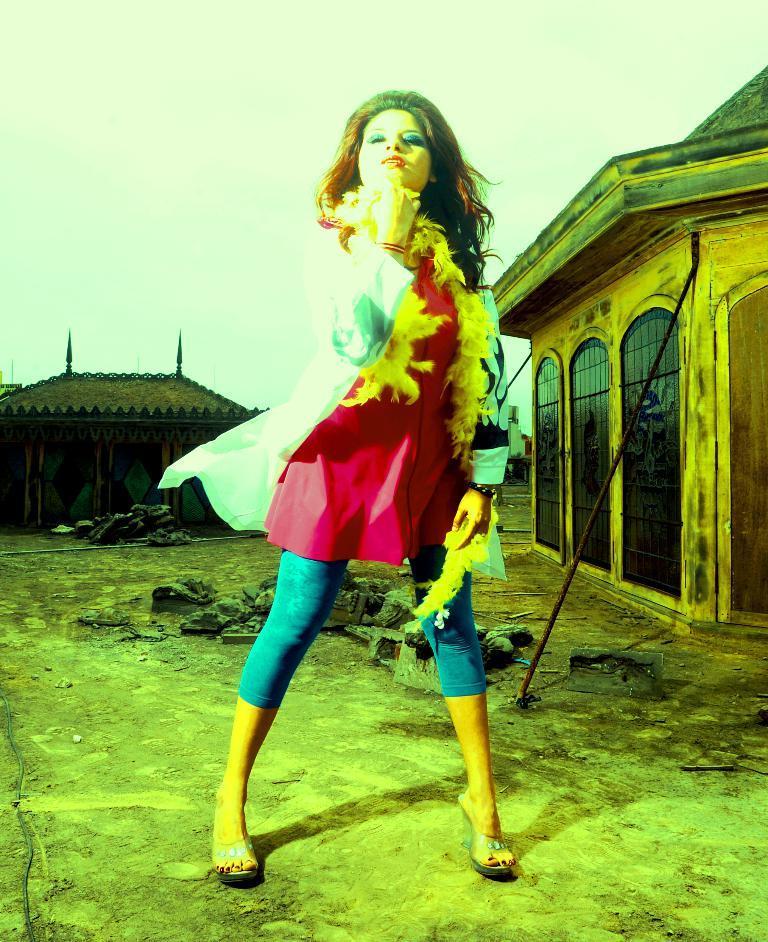In one or two sentences, can you explain what this image depicts? In this picture we can see a woman, she is standing, behind to her we can see few houses. 